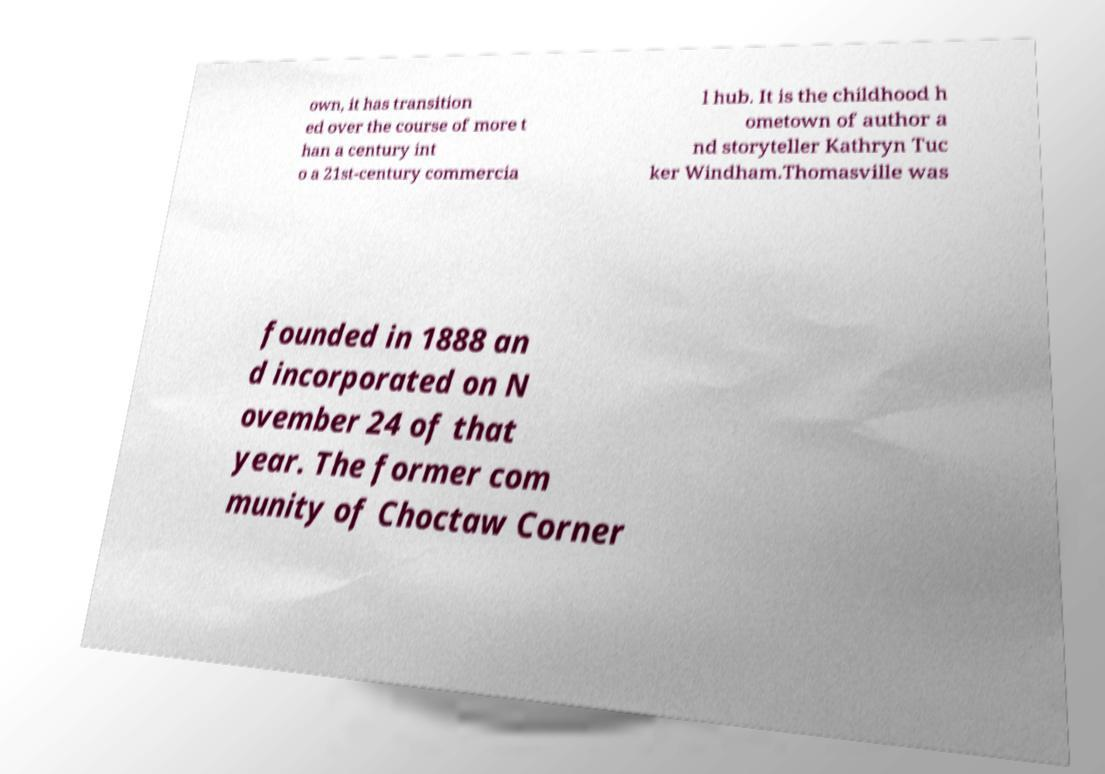I need the written content from this picture converted into text. Can you do that? own, it has transition ed over the course of more t han a century int o a 21st-century commercia l hub. It is the childhood h ometown of author a nd storyteller Kathryn Tuc ker Windham.Thomasville was founded in 1888 an d incorporated on N ovember 24 of that year. The former com munity of Choctaw Corner 